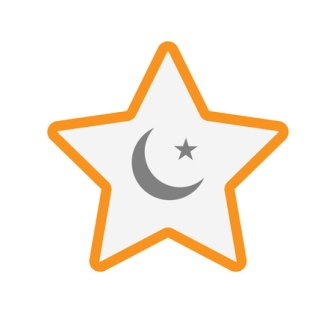If this image was part of a dream, what could it signify about the dreamer's subconscious? The presence of the star and moon in a dream could signify deep-seated desires for guidance and inner peace within the dreamer's subconscious. The star, with its vibrant outline, might represent a yearning for clarity, ambition, and personal growth. Positioned at the core of this guiding light, the crescent moon symbolizes a need for balance, introspection, and tranquility. Together, these symbols could suggest the dreamer's subconscious navigation towards a harmonious state of being, balancing their aspirations with a nurturing sense of inner calm and reflection. Craft a poetic verse inspired by this dream symbol. Within the silent night, a star burns bright,
With dreams of gold and whispers of flight.
A crescent moon's serene embrace,
Guides weary souls through time and space.
In dreams we chase the glowing light,
Seeking balance in the cosmic night. 